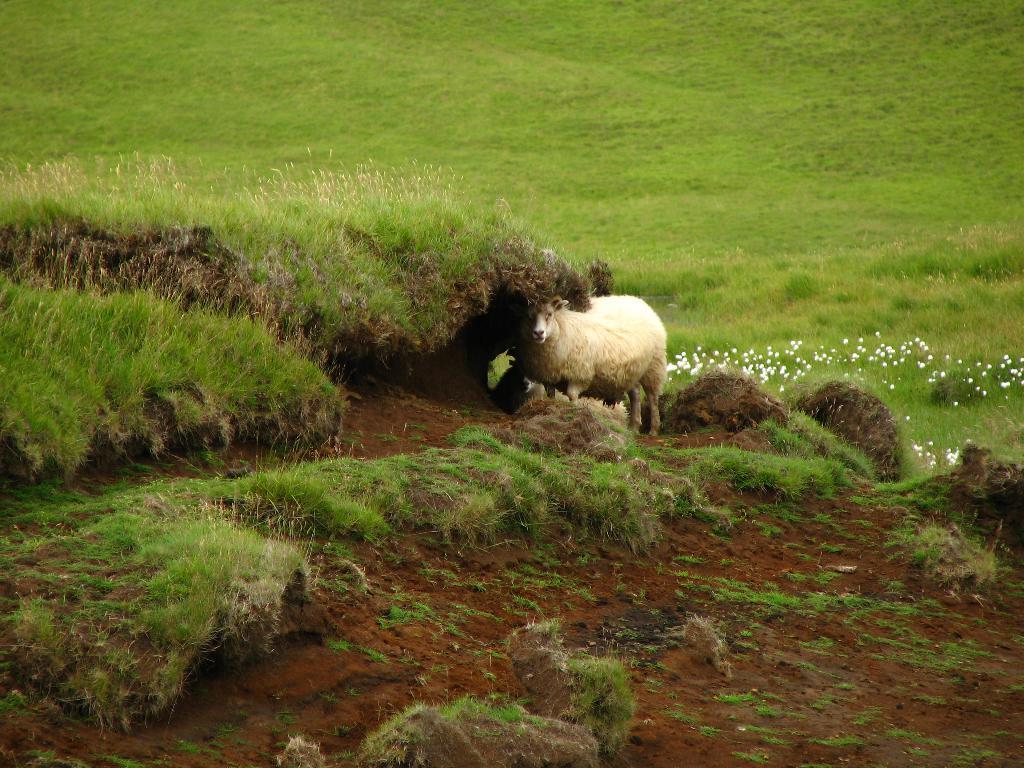Please provide a concise description of this image. In the image we can see there is a sheep standing on the ground and the ground is covered with grass and mud. 